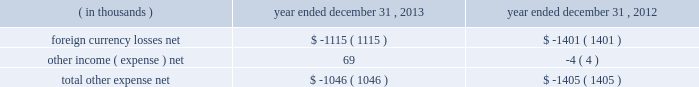Other expense , net : the company's other expense consists of the following: .
Income tax provision : the company recorded income tax expense of $ 77.2 million and had income before income taxes of $ 322.5 million for the year ended december 31 , 2013 , representing an effective tax rate of 23.9% ( 23.9 % ) .
During the year ended december 31 , 2012 , the company recorded income tax expense of $ 90.1 million and had income before income taxes of $ 293.5 million , representing an effective tax rate of 30.7% ( 30.7 % ) .
In december 2013 , the company received notice from the irs that the joint committee on taxation took no exception to the company's tax returns that were filed for 2009 and 2010 .
An $ 11.0 million tax benefit was recognized in the company's 2013 financial results as the company had effectively settled uncertainty regarding the realization of refund claims filed in connection with the 2009 and 2010 returns .
In the u.s. , which is the largest jurisdiction where the company receives such a tax credit , the availability of the research and development credit expired at the end of the 2011 tax year .
In january 2013 , the u.s .
Congress passed legislation that reinstated the research and development credit retroactive to 2012 .
The income tax provision for the year ended december 31 , 2013 includes approximately $ 2.3 million related to the reinstated research and development credit for 2012 activity .
The decrease in the effective tax rate from the prior year is primarily due to the release of an uncertain tax position mentioned above , the reinstatement of the u.s .
Research and development credit mentioned above , and cash repatriation activities .
When compared to the federal and state combined statutory rate , the effective tax rates for the years ended december 31 , 2013 and 2012 were favorably impacted by lower statutory tax rates in many of the company 2019s foreign jurisdictions , the domestic manufacturing deduction and tax benefits associated with the merger of the company 2019s japan subsidiaries in 2010 .
Net income : the company 2019s net income for the year ended december 31 , 2013 was $ 245.3 million as compared to net income of $ 203.5 million for the year ended december 31 , 2012 .
Diluted earnings per share was $ 2.58 for the year ended december 31 , 2013 and $ 2.14 for the year ended december 31 , 2012 .
The weighted average shares used in computing diluted earnings per share were 95.1 million and 95.0 million for the years ended december 31 , 2013 and 2012 , respectively .
Table of contents .
What was the percentage change in the foreign currency losses net from 2012 to 2013? 
Computations: ((1115 - 1401) / 1401)
Answer: -0.20414. 